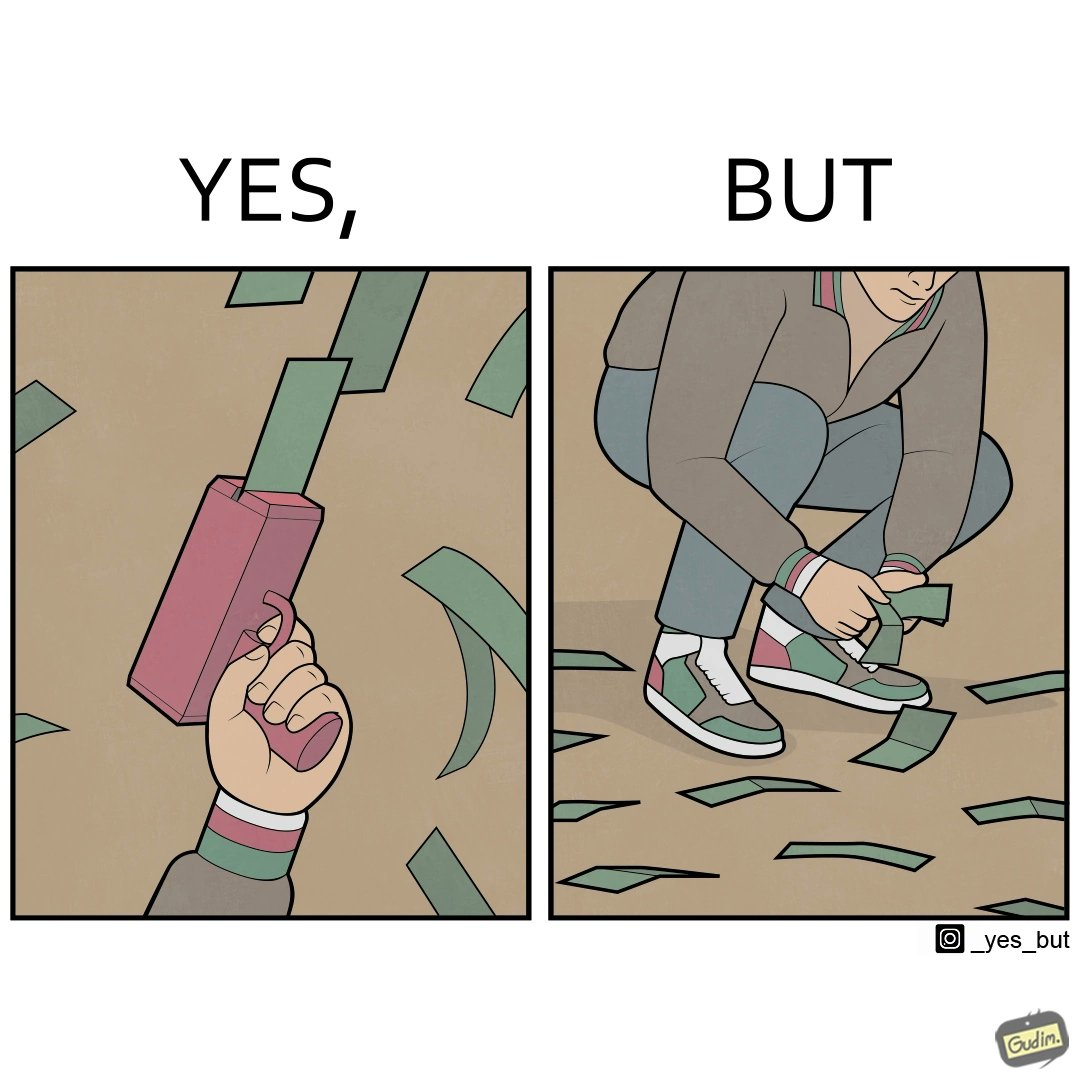Is there satirical content in this image? Yes, this image is satirical. 